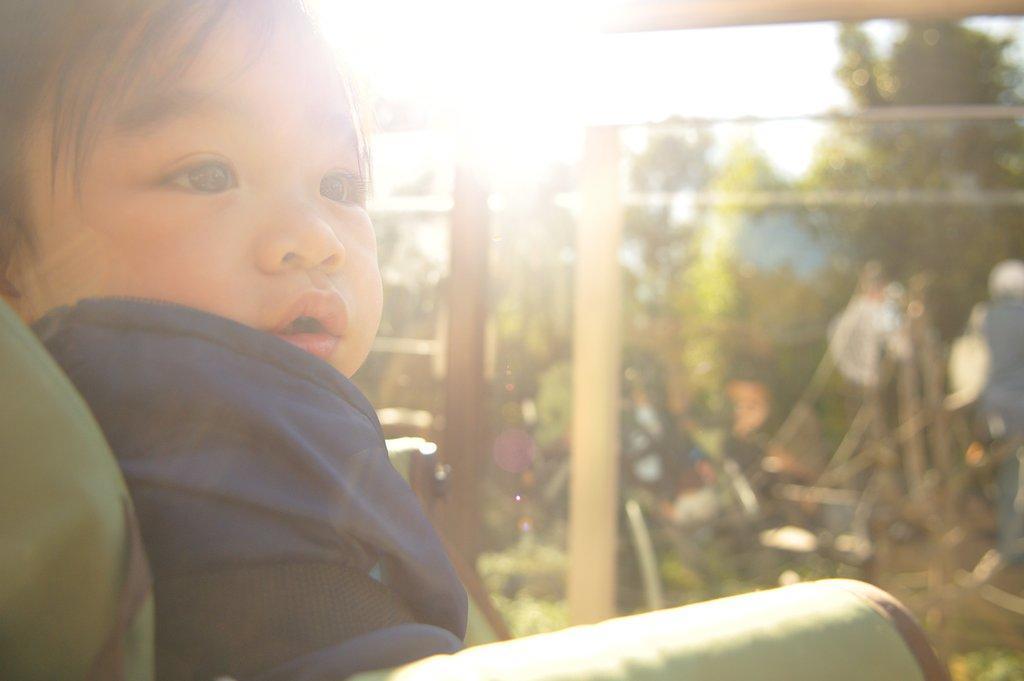Could you give a brief overview of what you see in this image? There is a baby in violet color dress sitting on a chair. In the background, there are two poles near plants, there are trees and there is sky. 